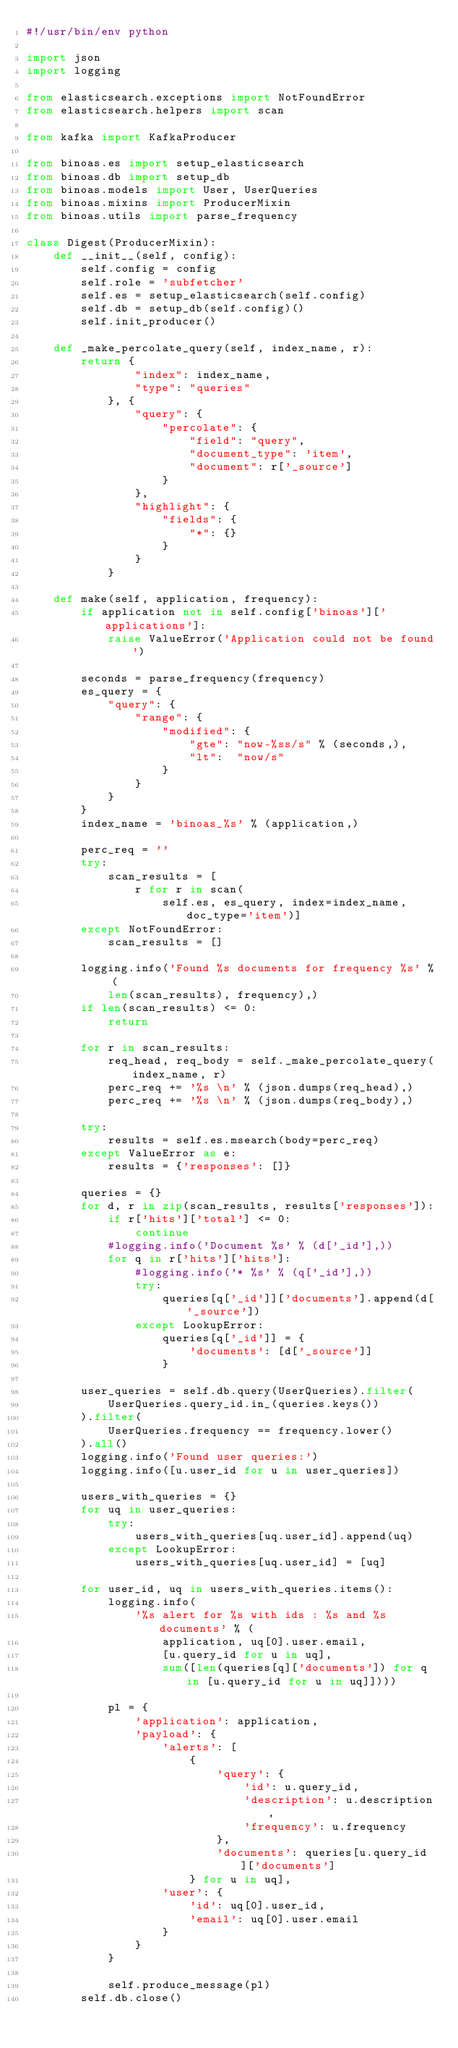Convert code to text. <code><loc_0><loc_0><loc_500><loc_500><_Python_>#!/usr/bin/env python

import json
import logging

from elasticsearch.exceptions import NotFoundError
from elasticsearch.helpers import scan

from kafka import KafkaProducer

from binoas.es import setup_elasticsearch
from binoas.db import setup_db
from binoas.models import User, UserQueries
from binoas.mixins import ProducerMixin
from binoas.utils import parse_frequency

class Digest(ProducerMixin):
    def __init__(self, config):
        self.config = config
        self.role = 'subfetcher'
        self.es = setup_elasticsearch(self.config)
        self.db = setup_db(self.config)()
        self.init_producer()

    def _make_percolate_query(self, index_name, r):
        return {
                "index": index_name,
                "type": "queries"
            }, {
                "query": {
                    "percolate": {
                        "field": "query",
                        "document_type": 'item',
                        "document": r['_source']
                    }
                },
                "highlight": {
                    "fields": {
                        "*": {}
                    }
                }
            }

    def make(self, application, frequency):
        if application not in self.config['binoas']['applications']:
            raise ValueError('Application could not be found')

        seconds = parse_frequency(frequency)
        es_query = {
            "query": {
                "range": {
                    "modified": {
                        "gte": "now-%ss/s" % (seconds,),
                        "lt":  "now/s"
                    }
                }
            }
        }
        index_name = 'binoas_%s' % (application,)

        perc_req = ''
        try:
            scan_results = [
                r for r in scan(
                    self.es, es_query, index=index_name, doc_type='item')]
        except NotFoundError:
            scan_results = []

        logging.info('Found %s documents for frequency %s' % (
            len(scan_results), frequency),)
        if len(scan_results) <= 0:
            return

        for r in scan_results:
            req_head, req_body = self._make_percolate_query(index_name, r)
            perc_req += '%s \n' % (json.dumps(req_head),)
            perc_req += '%s \n' % (json.dumps(req_body),)

        try:
            results = self.es.msearch(body=perc_req)
        except ValueError as e:
            results = {'responses': []}

        queries = {}
        for d, r in zip(scan_results, results['responses']):
            if r['hits']['total'] <= 0:
                continue
            #logging.info('Document %s' % (d['_id'],))
            for q in r['hits']['hits']:
                #logging.info('* %s' % (q['_id'],))
                try:
                    queries[q['_id']]['documents'].append(d['_source'])
                except LookupError:
                    queries[q['_id']] = {
                        'documents': [d['_source']]
                    }

        user_queries = self.db.query(UserQueries).filter(
            UserQueries.query_id.in_(queries.keys())
        ).filter(
            UserQueries.frequency == frequency.lower()
        ).all()
        logging.info('Found user queries:')
        logging.info([u.user_id for u in user_queries])

        users_with_queries = {}
        for uq in user_queries:
            try:
                users_with_queries[uq.user_id].append(uq)
            except LookupError:
                users_with_queries[uq.user_id] = [uq]

        for user_id, uq in users_with_queries.items():
            logging.info(
                '%s alert for %s with ids : %s and %s documents' % (
                    application, uq[0].user.email,
                    [u.query_id for u in uq],
                    sum([len(queries[q]['documents']) for q in [u.query_id for u in uq]])))

            pl = {
                'application': application,
                'payload': {
                    'alerts': [
                        {
                            'query': {
                                'id': u.query_id,
                                'description': u.description,
                                'frequency': u.frequency
                            },
                            'documents': queries[u.query_id]['documents']
                        } for u in uq],
                    'user': {
                        'id': uq[0].user_id,
                        'email': uq[0].user.email
                    }
                }
            }

            self.produce_message(pl)
        self.db.close()
</code> 